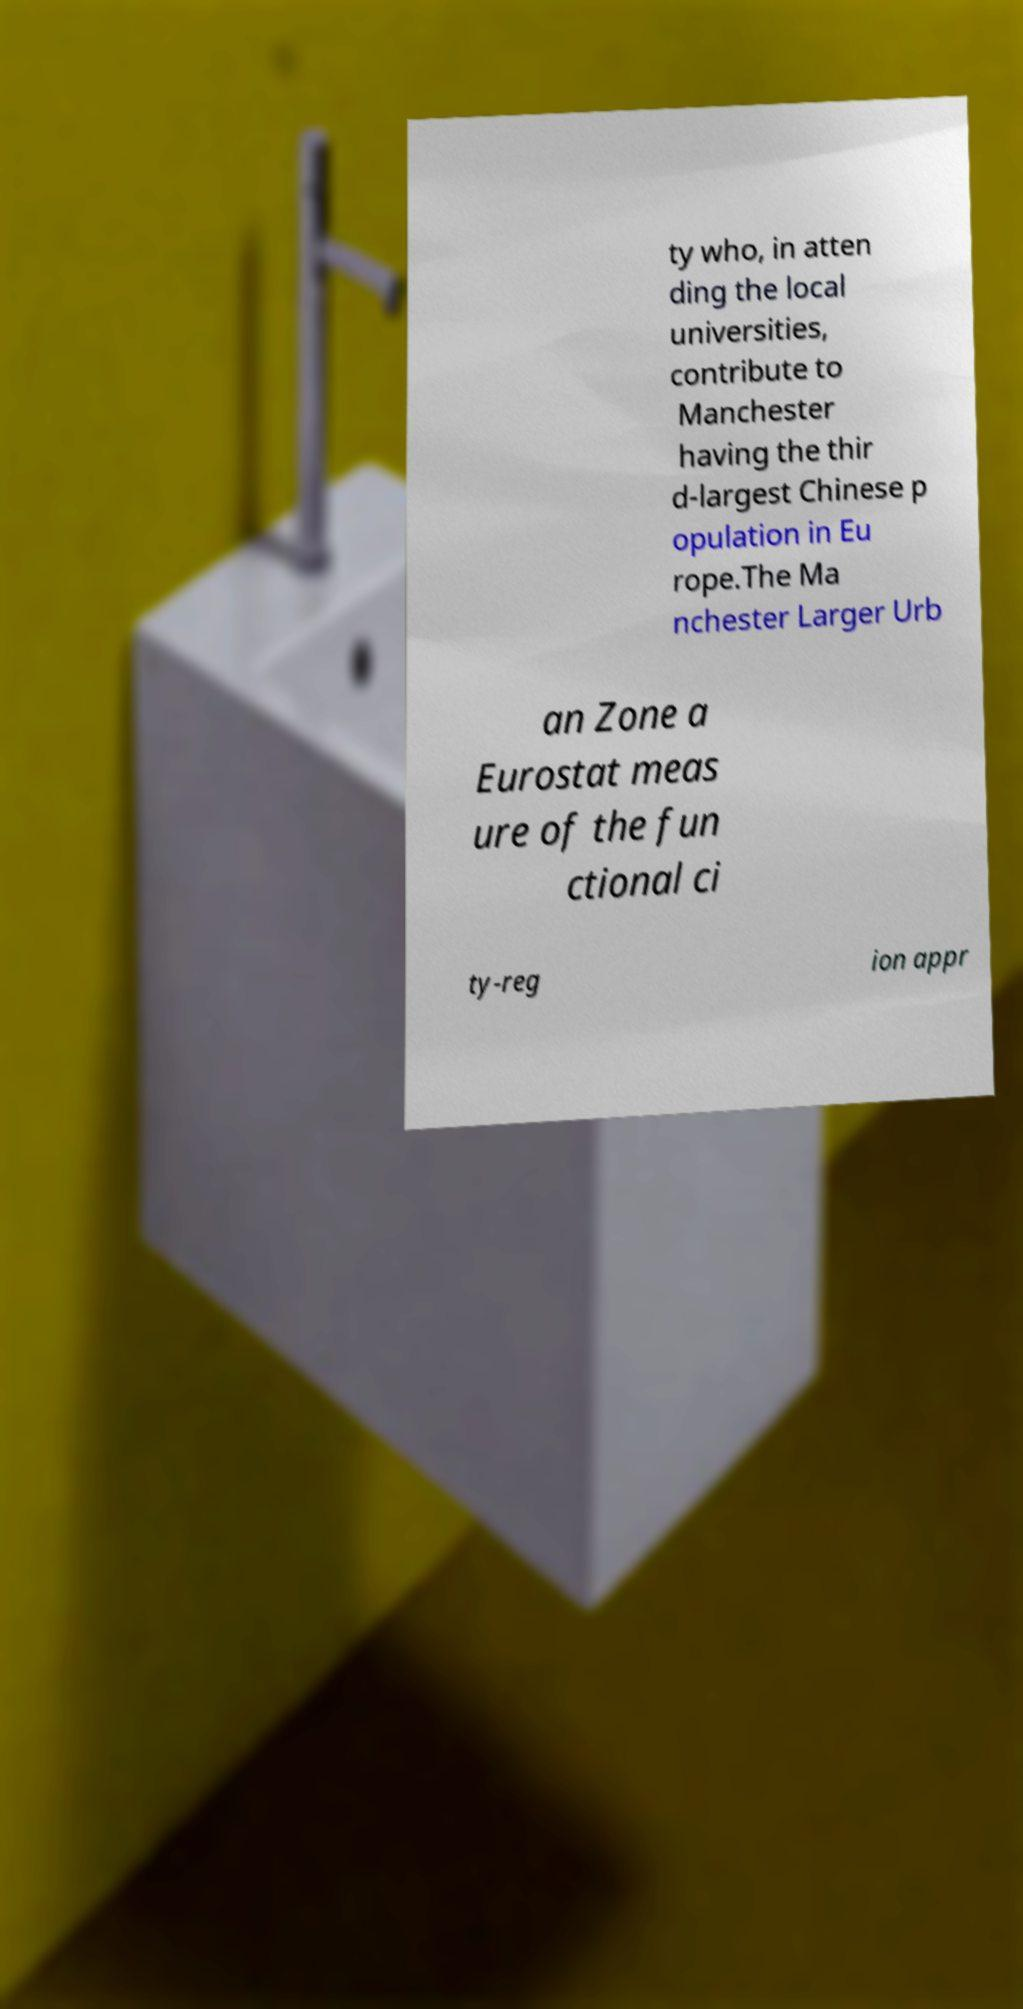Could you extract and type out the text from this image? ty who, in atten ding the local universities, contribute to Manchester having the thir d-largest Chinese p opulation in Eu rope.The Ma nchester Larger Urb an Zone a Eurostat meas ure of the fun ctional ci ty-reg ion appr 